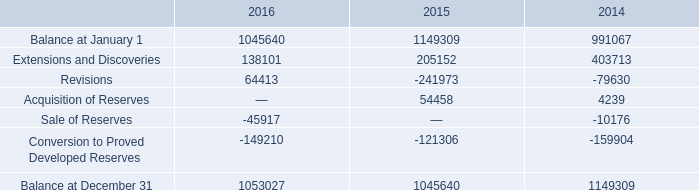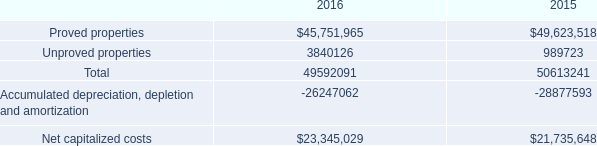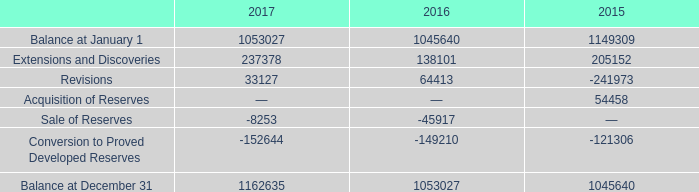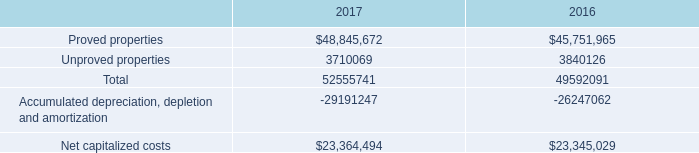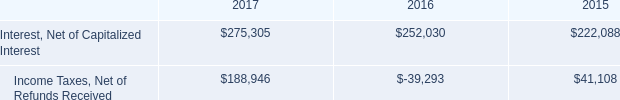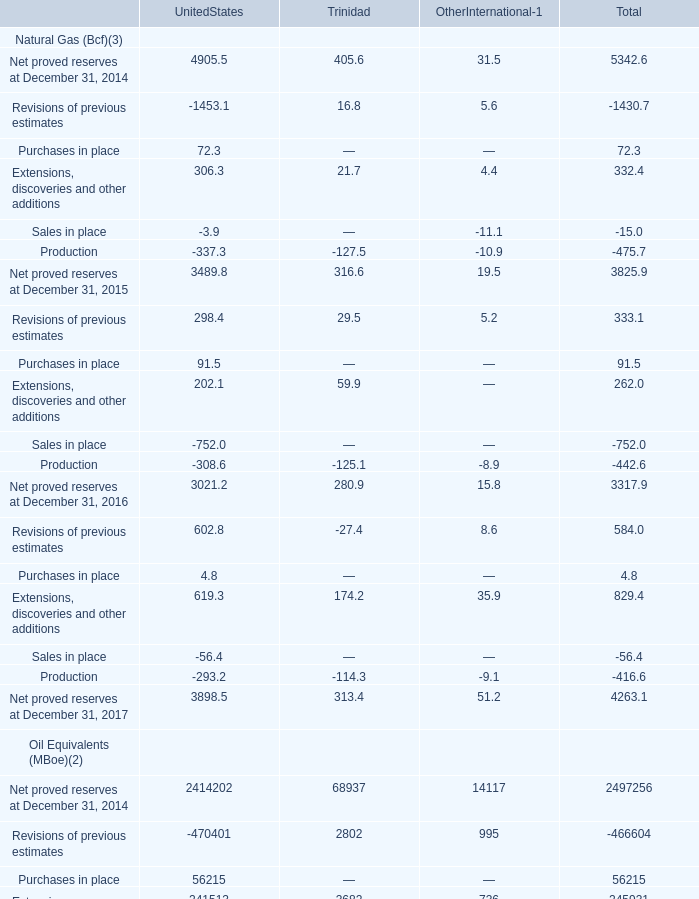what is the increase observed in accrued capital expenditures during 2016 and 2017? 
Computations: ((475 / 388) - 1)
Answer: 0.22423. 